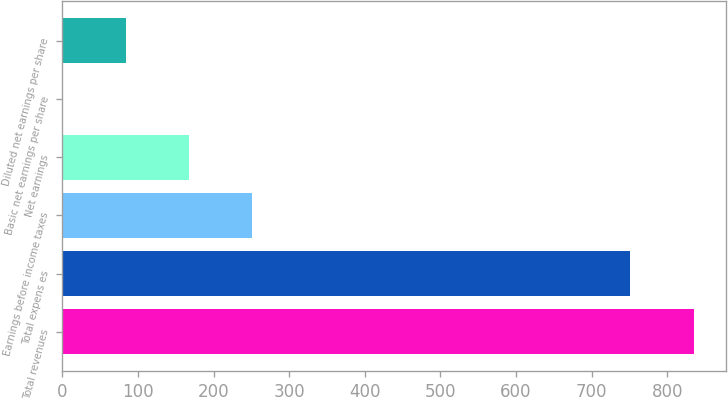Convert chart to OTSL. <chart><loc_0><loc_0><loc_500><loc_500><bar_chart><fcel>Total revenues<fcel>Total expens es<fcel>Earnings before income taxes<fcel>Net earnings<fcel>Basic net earnings per share<fcel>Diluted net earnings per share<nl><fcel>835.8<fcel>750.3<fcel>251.13<fcel>167.61<fcel>0.57<fcel>84.09<nl></chart> 